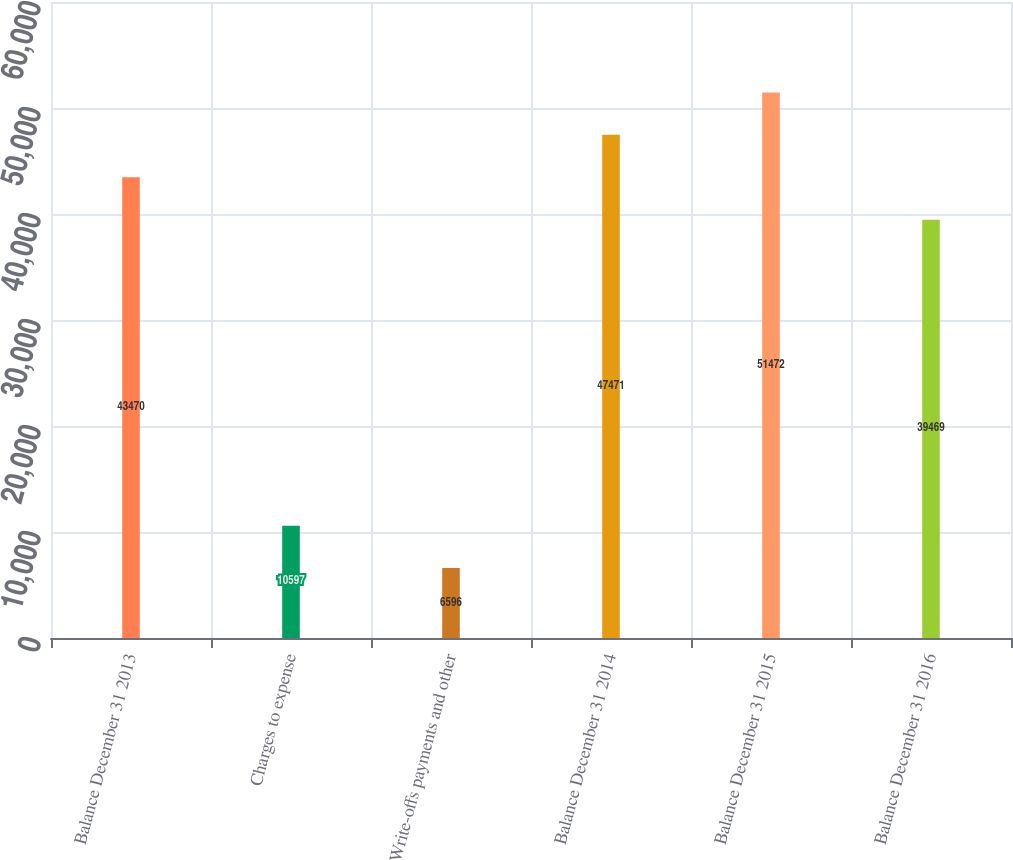Convert chart to OTSL. <chart><loc_0><loc_0><loc_500><loc_500><bar_chart><fcel>Balance December 31 2013<fcel>Charges to expense<fcel>Write-offs payments and other<fcel>Balance December 31 2014<fcel>Balance December 31 2015<fcel>Balance December 31 2016<nl><fcel>43470<fcel>10597<fcel>6596<fcel>47471<fcel>51472<fcel>39469<nl></chart> 